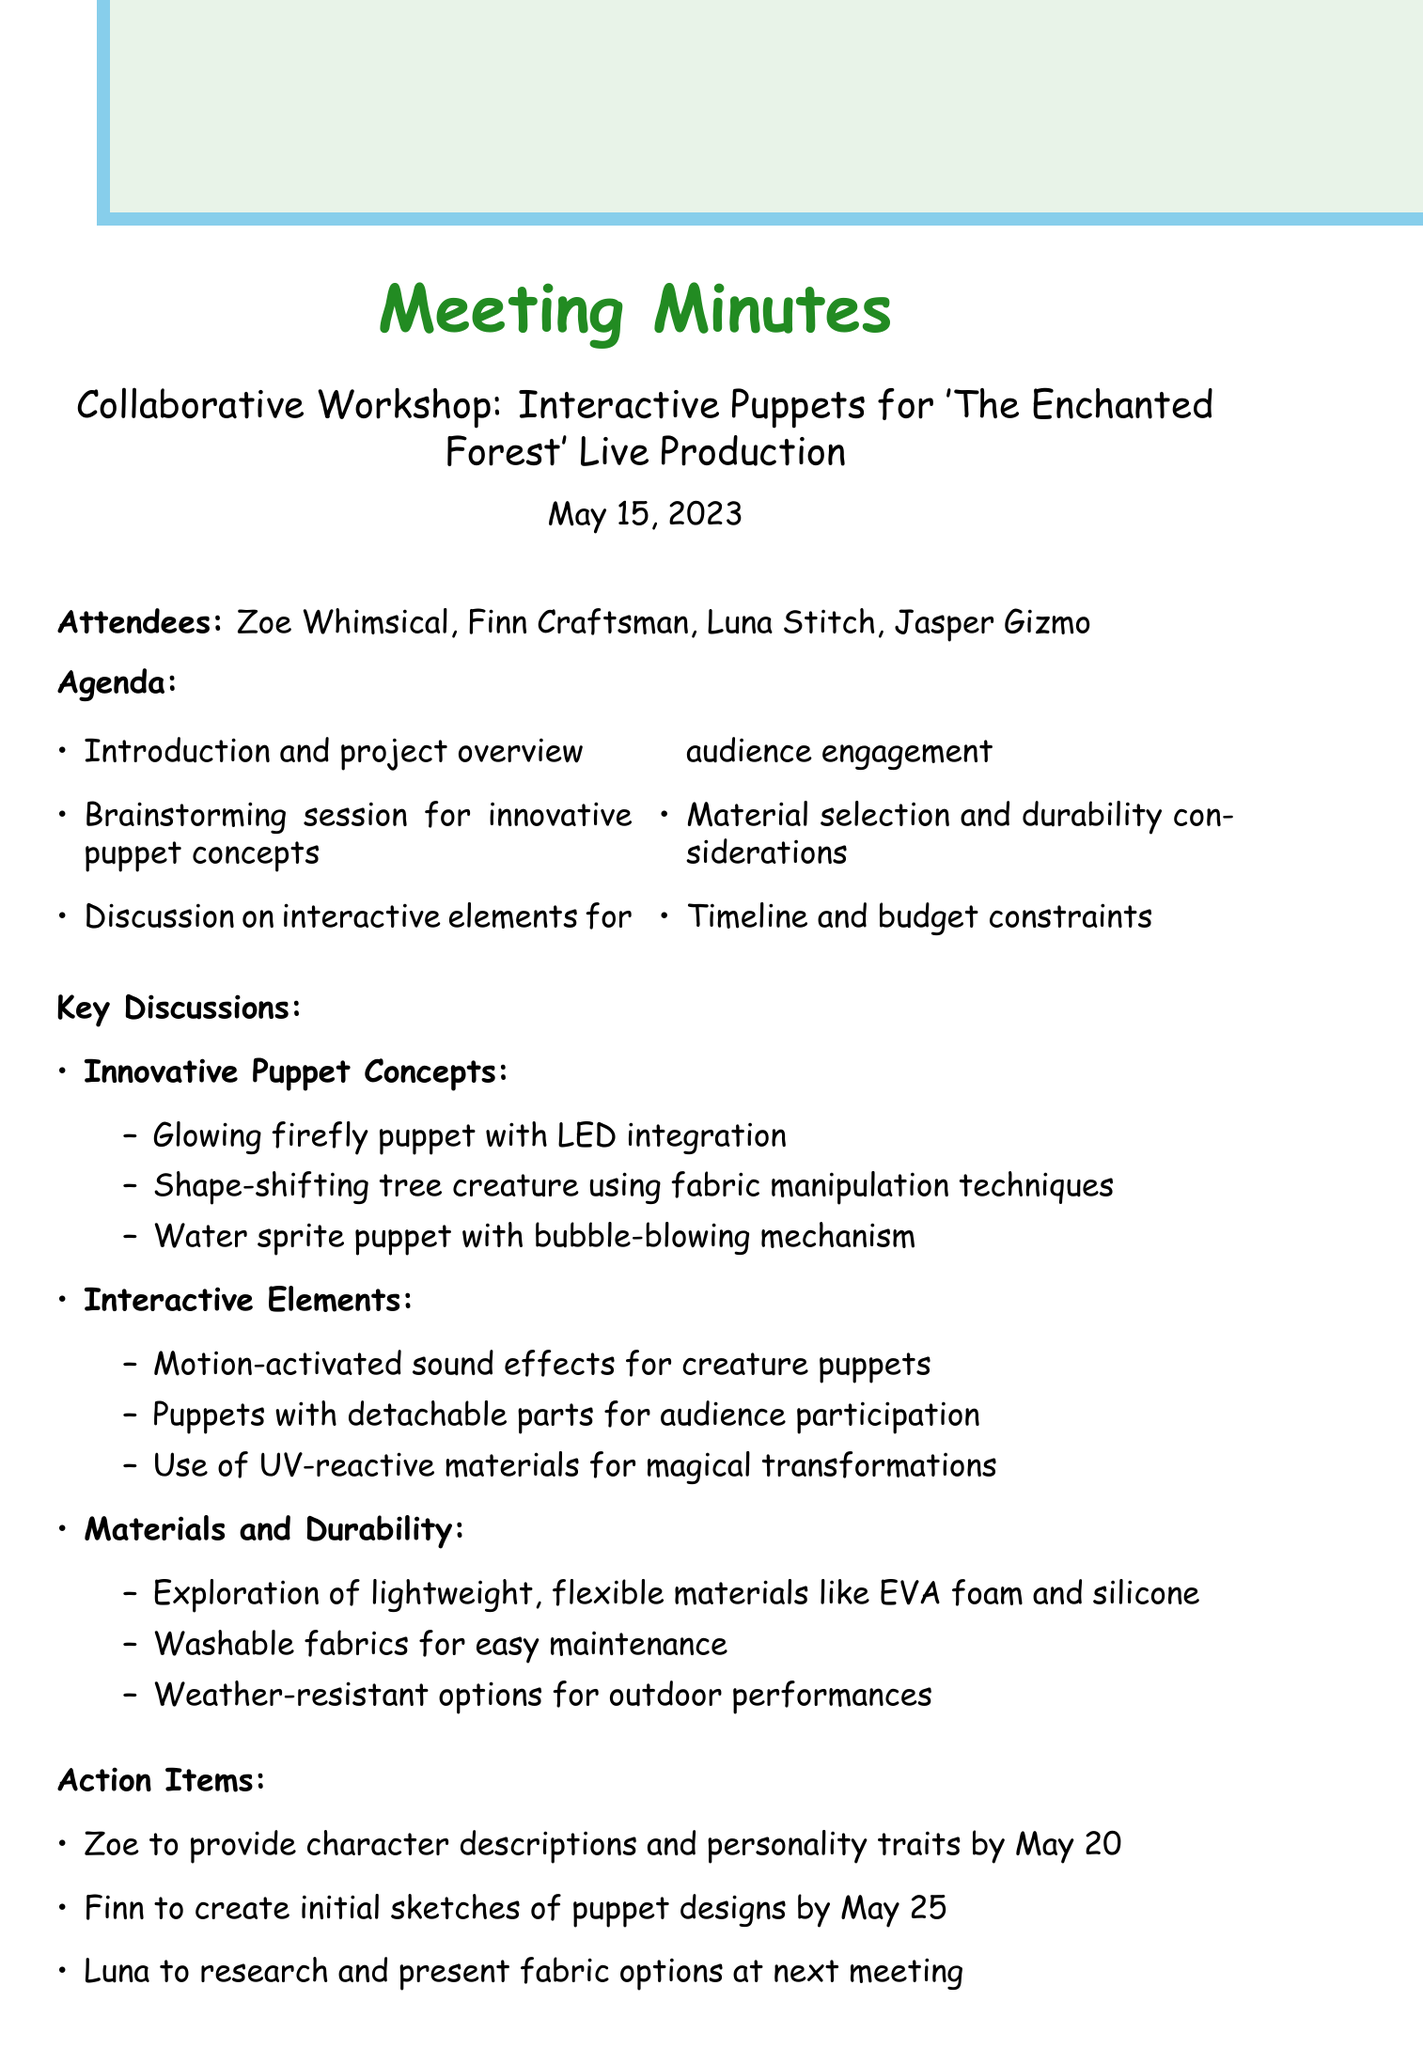What is the date of the meeting? The date of the meeting is stated at the top of the document.
Answer: May 15, 2023 Who is the Lead Prop Designer? The document lists the attendees, one of whom is identified as the Lead Prop Designer.
Answer: Finn Craftsman What is one of the innovative puppet concepts discussed? The key discussions section outlines several innovative puppet concepts, one of which can be identified.
Answer: Glowing firefly puppet with LED integration What is the next meeting date? The next meeting date is clearly mentioned in the document's concluding section.
Answer: May 29, 2023 What is one material explored for puppets? The discussions on materials and durability cover possible materials that were considered, providing specific examples.
Answer: EVA foam How many action items are listed in the document? By counting the action items section, the total number can be determined.
Answer: 4 What interactive element involves audience participation? The key discussions on interactive elements provide options for audience engagement, including specific designs.
Answer: Puppets with detachable parts What is the name of the scriptwriter? The list of attendees includes the scriptwriter's name at the start of the document.
Answer: Zoe Whimsical What theme is the live production based on? The title of the workshop indicates the thematic focus of the live production discussed.
Answer: The Enchanted Forest 